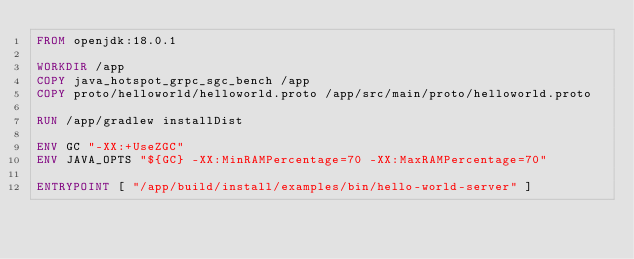Convert code to text. <code><loc_0><loc_0><loc_500><loc_500><_Dockerfile_>FROM openjdk:18.0.1

WORKDIR /app
COPY java_hotspot_grpc_sgc_bench /app
COPY proto/helloworld/helloworld.proto /app/src/main/proto/helloworld.proto

RUN /app/gradlew installDist

ENV GC "-XX:+UseZGC"
ENV JAVA_OPTS "${GC} -XX:MinRAMPercentage=70 -XX:MaxRAMPercentage=70"

ENTRYPOINT [ "/app/build/install/examples/bin/hello-world-server" ]
</code> 